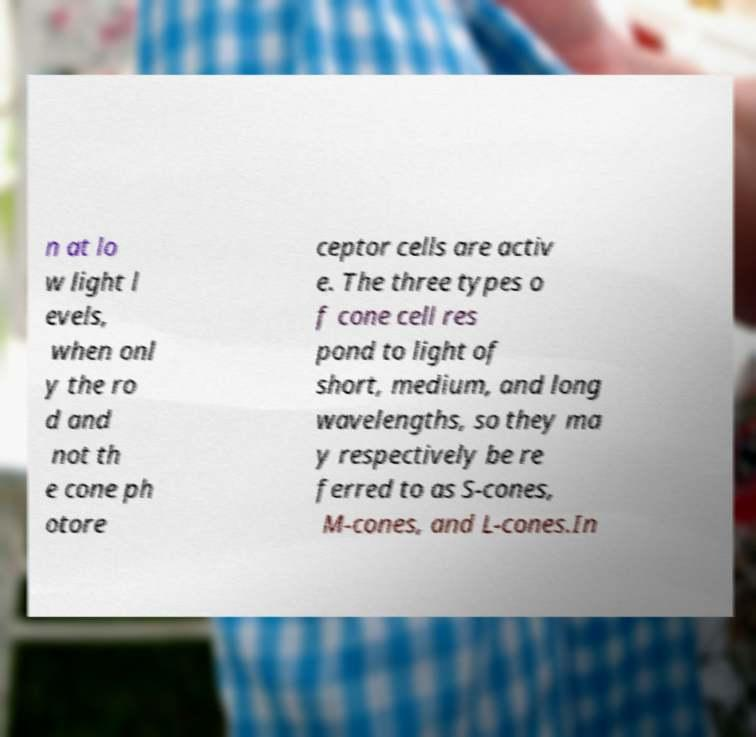What messages or text are displayed in this image? I need them in a readable, typed format. n at lo w light l evels, when onl y the ro d and not th e cone ph otore ceptor cells are activ e. The three types o f cone cell res pond to light of short, medium, and long wavelengths, so they ma y respectively be re ferred to as S-cones, M-cones, and L-cones.In 